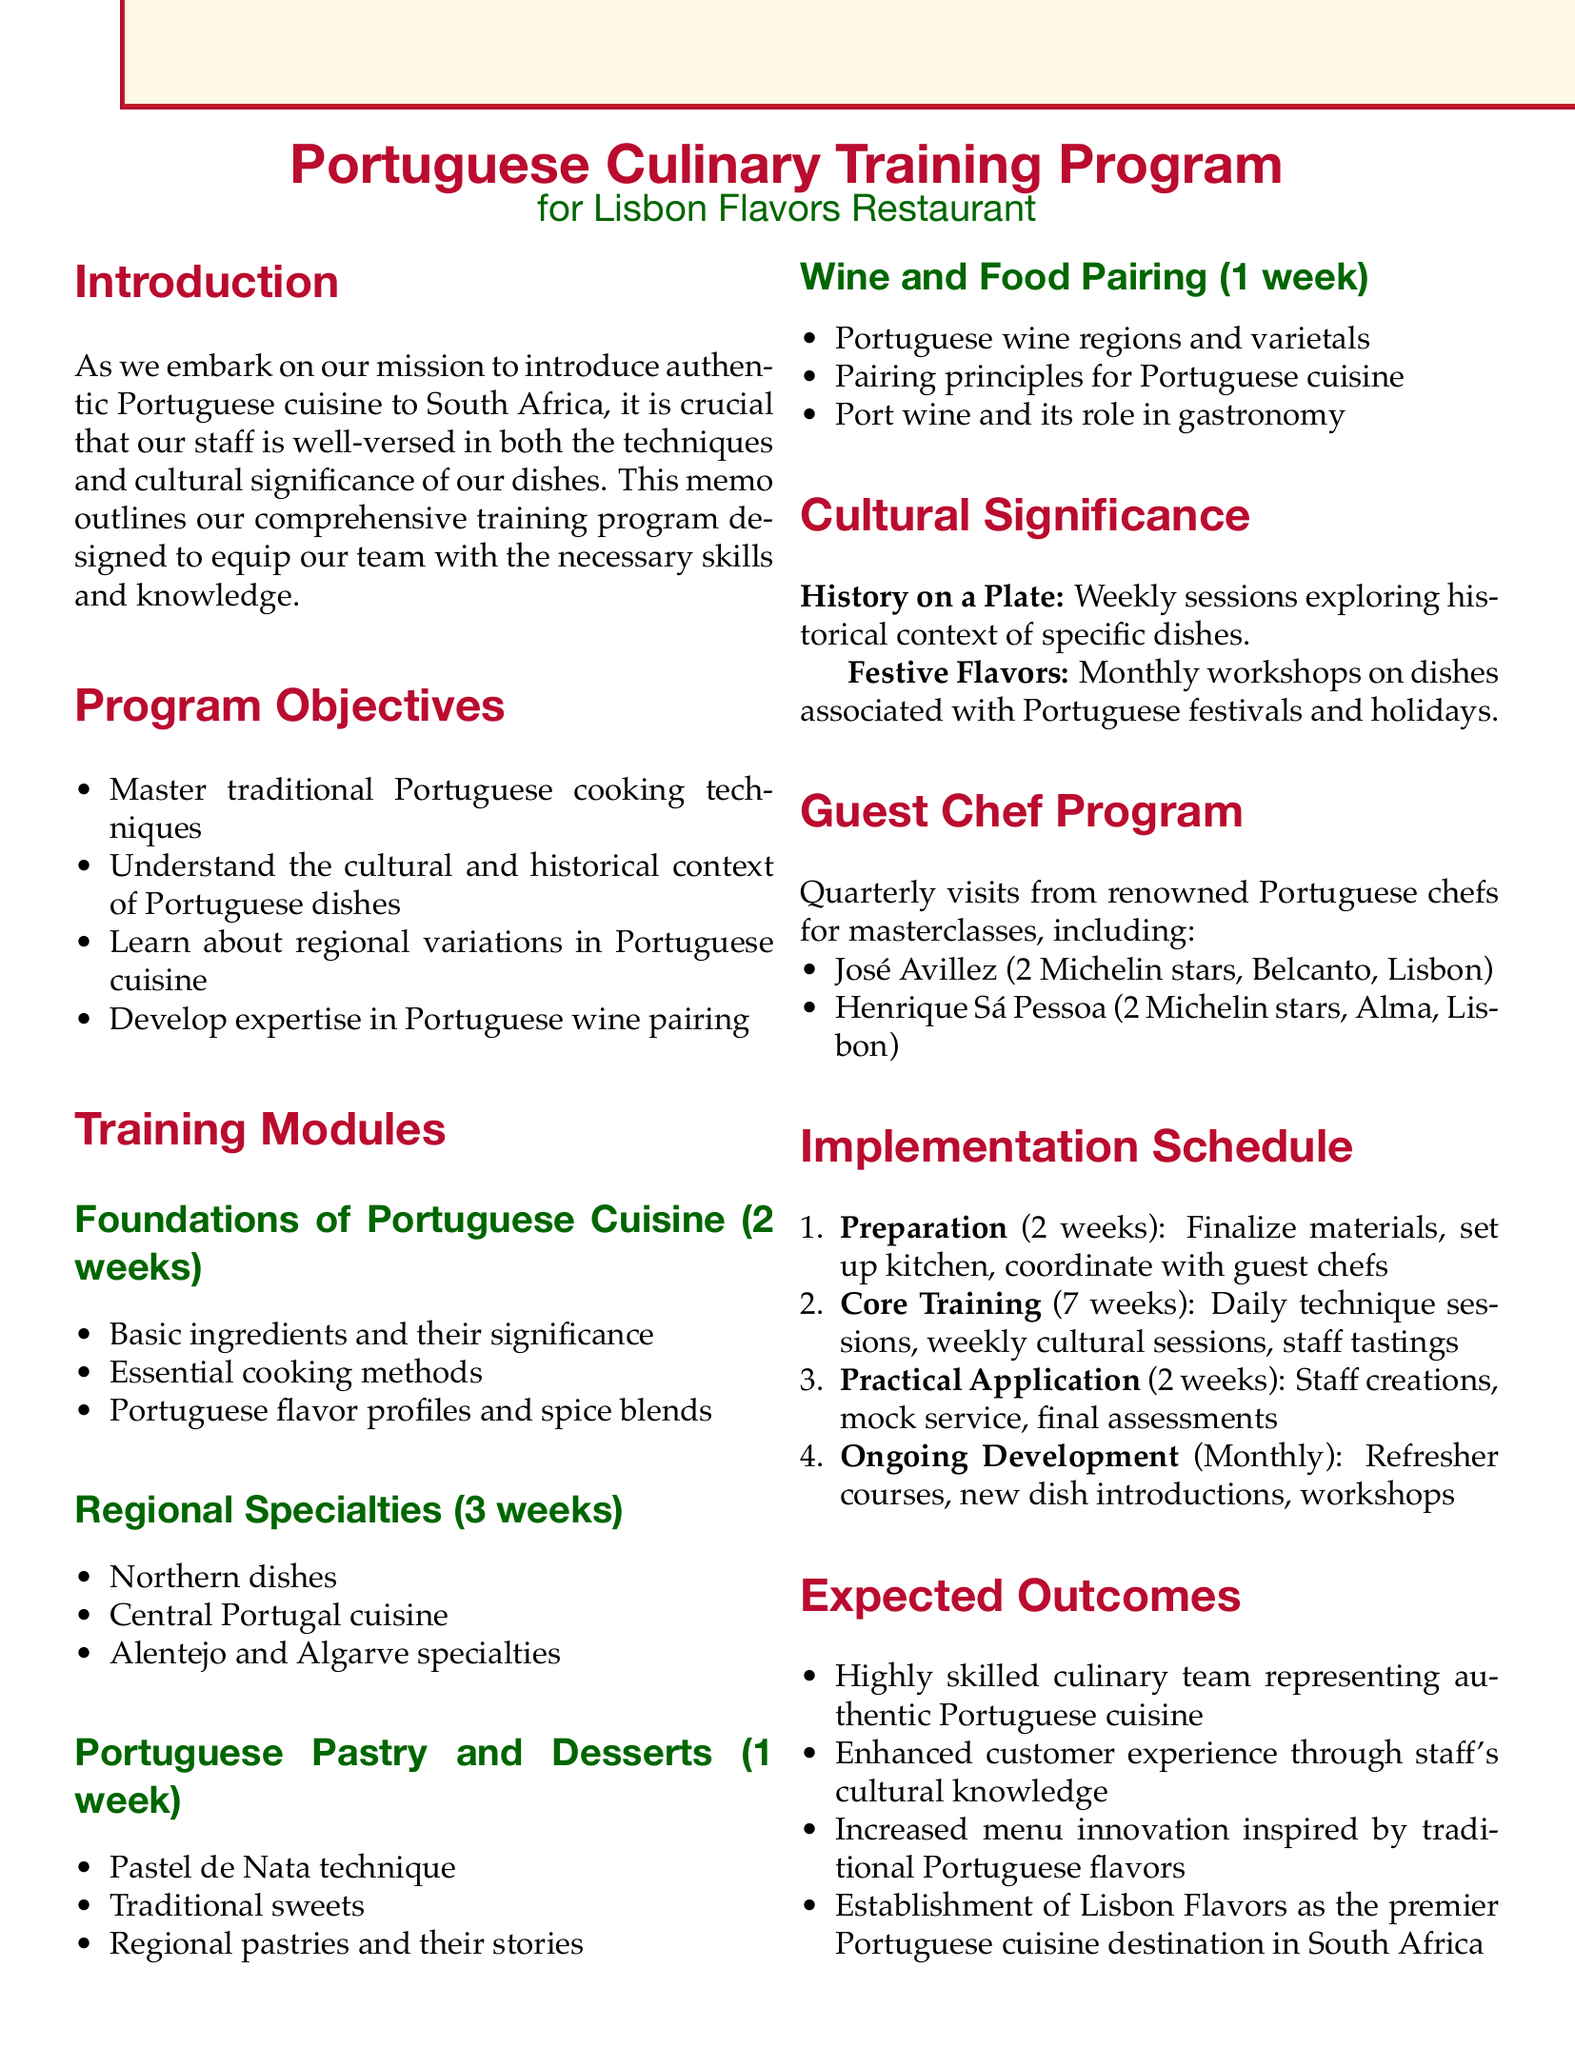what is the title of the memo? The title of the memo is stated at the beginning, introducing the program.
Answer: Portuguese Culinary Training Program for Lisbon Flavors Restaurant how many weeks does the module "Foundations of Portuguese Cuisine" last? The duration of this training module is explicitly mentioned in the document.
Answer: 2 weeks who are the confirmed guest chefs for the program? The text provides specific names of renowned chefs who will visit for masterclasses.
Answer: José Avillez and Henrique Sá Pessoa what phase comes after "Preparation" in the implementation schedule? The phases listed in the schedule are sequentially ordered, making it easy to identify the next phase.
Answer: Core Training what is one of the expected outcomes of the training program? The memo outlines the goals of the training program, indicating what is anticipated after its completion.
Answer: A highly skilled culinary team capable of authentically representing Portuguese cuisine how often will the "Ongoing Development" activities occur? The frequency of the ongoing development activities is clearly stated in the implementation schedule.
Answer: Monthly what is one topic covered in the "Wine and Food Pairing" module? The document lists specific topics within each training module, one of which relates to the wine pairings.
Answer: Portuguese wine regions and varietals how many weeks is the total duration for the training program? To find the total duration, one can sum the duration of each phase presented in the implementation schedule.
Answer: 11 weeks what type of significance does the "History on a Plate" session explore? The description of the session indicates the thematic focus, which is historical context related to dishes.
Answer: Historical context of specific dishes 